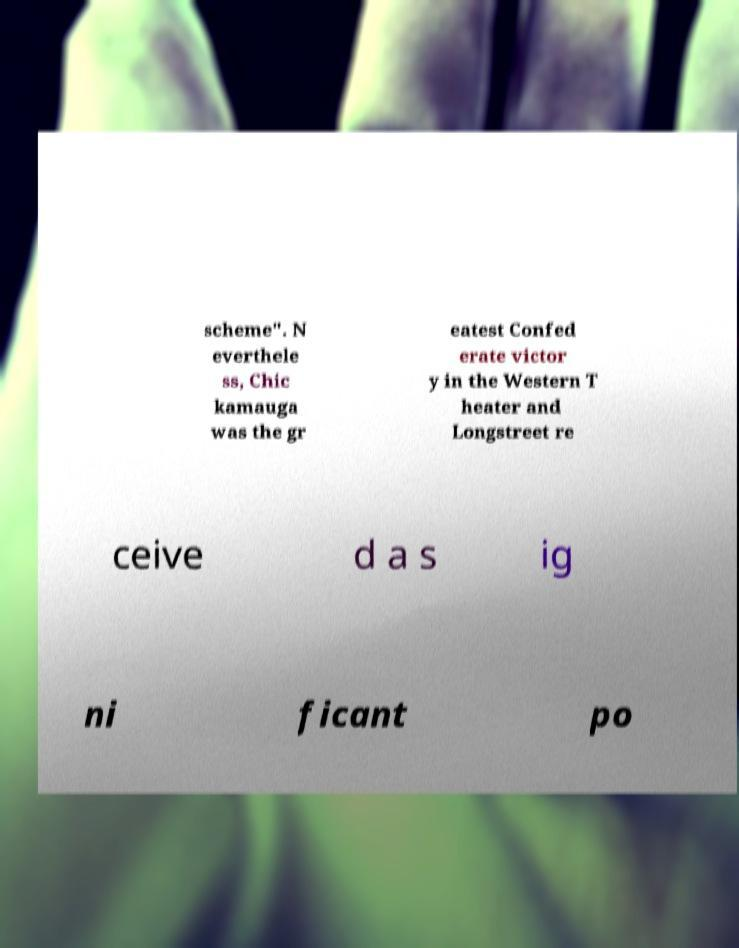Can you accurately transcribe the text from the provided image for me? scheme". N everthele ss, Chic kamauga was the gr eatest Confed erate victor y in the Western T heater and Longstreet re ceive d a s ig ni ficant po 